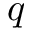<formula> <loc_0><loc_0><loc_500><loc_500>q</formula> 